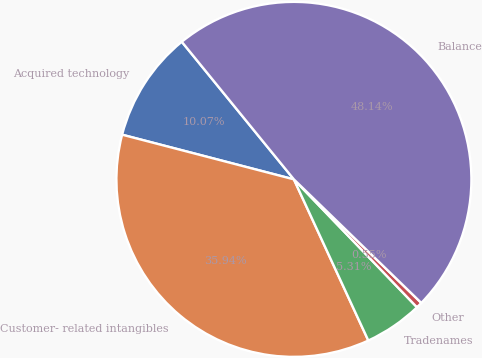<chart> <loc_0><loc_0><loc_500><loc_500><pie_chart><fcel>Acquired technology<fcel>Customer- related intangibles<fcel>Tradenames<fcel>Other<fcel>Balance<nl><fcel>10.07%<fcel>35.94%<fcel>5.31%<fcel>0.55%<fcel>48.14%<nl></chart> 